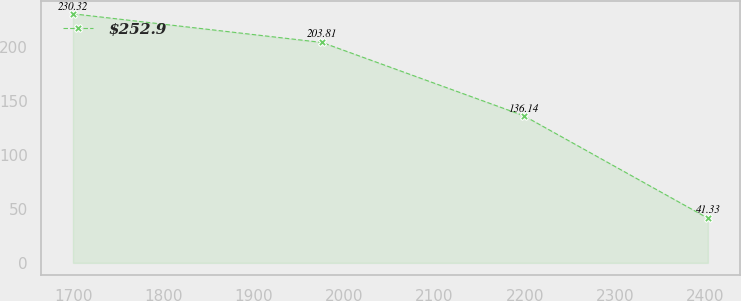Convert chart to OTSL. <chart><loc_0><loc_0><loc_500><loc_500><line_chart><ecel><fcel>$252.9<nl><fcel>1699.27<fcel>230.32<nl><fcel>1975.49<fcel>203.81<nl><fcel>2198.88<fcel>136.14<nl><fcel>2403.1<fcel>41.33<nl></chart> 